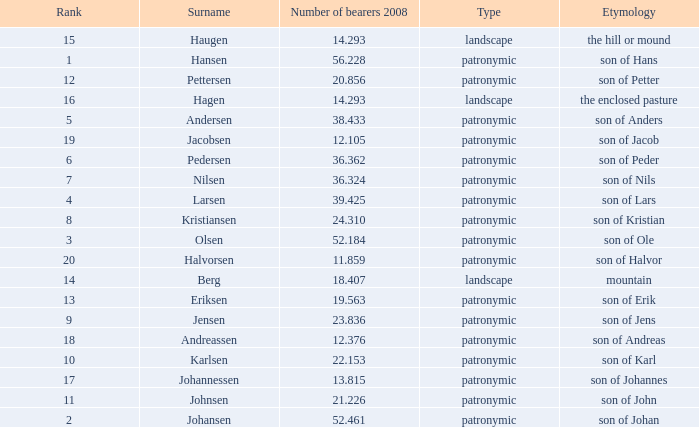What is Type, when Rank is greater than 6, when Number of Bearers 2008 is greater than 13.815, and when Surname is Eriksen? Patronymic. 